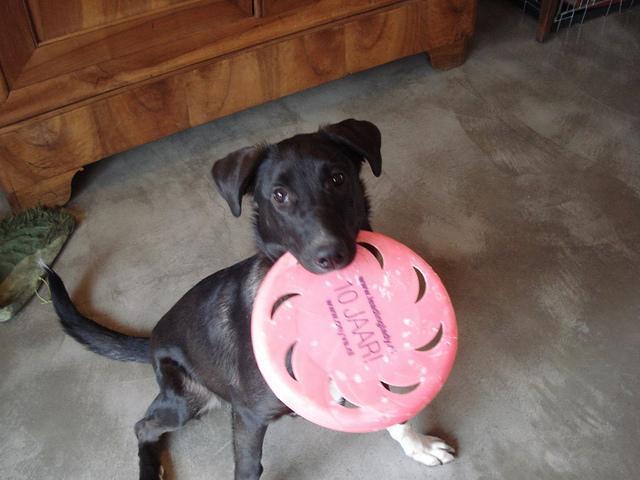How many giraffes are seen?
Give a very brief answer. 0. 